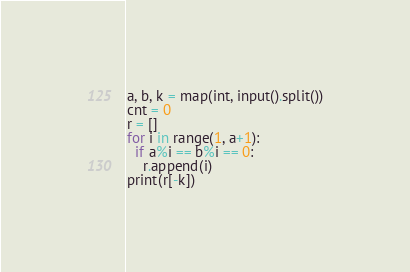Convert code to text. <code><loc_0><loc_0><loc_500><loc_500><_Python_>a, b, k = map(int, input().split())
cnt = 0
r = []
for i in range(1, a+1):
  if a%i == b%i == 0:
    r.append(i)
print(r[-k])</code> 